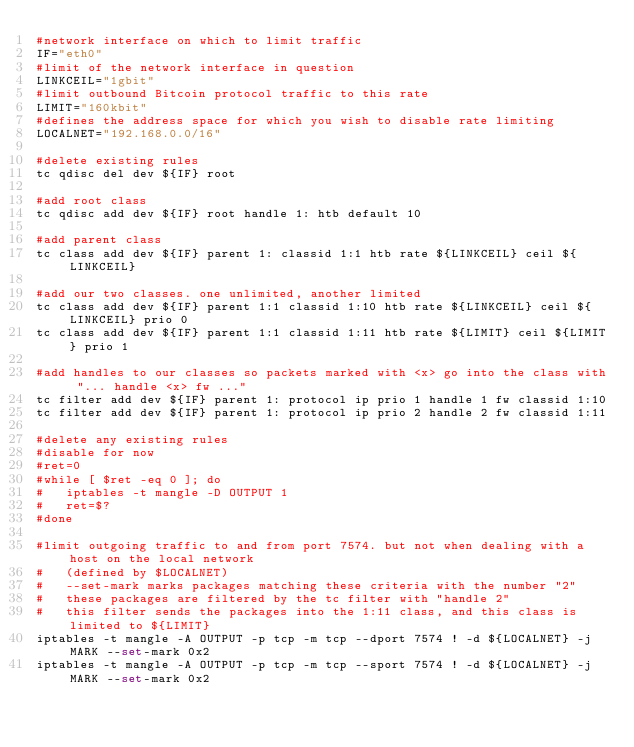<code> <loc_0><loc_0><loc_500><loc_500><_Bash_>#network interface on which to limit traffic
IF="eth0"
#limit of the network interface in question
LINKCEIL="1gbit"
#limit outbound Bitcoin protocol traffic to this rate
LIMIT="160kbit"
#defines the address space for which you wish to disable rate limiting
LOCALNET="192.168.0.0/16"

#delete existing rules
tc qdisc del dev ${IF} root

#add root class
tc qdisc add dev ${IF} root handle 1: htb default 10

#add parent class
tc class add dev ${IF} parent 1: classid 1:1 htb rate ${LINKCEIL} ceil ${LINKCEIL}

#add our two classes. one unlimited, another limited
tc class add dev ${IF} parent 1:1 classid 1:10 htb rate ${LINKCEIL} ceil ${LINKCEIL} prio 0
tc class add dev ${IF} parent 1:1 classid 1:11 htb rate ${LIMIT} ceil ${LIMIT} prio 1

#add handles to our classes so packets marked with <x> go into the class with "... handle <x> fw ..."
tc filter add dev ${IF} parent 1: protocol ip prio 1 handle 1 fw classid 1:10
tc filter add dev ${IF} parent 1: protocol ip prio 2 handle 2 fw classid 1:11

#delete any existing rules
#disable for now
#ret=0
#while [ $ret -eq 0 ]; do
#	iptables -t mangle -D OUTPUT 1
#	ret=$?
#done

#limit outgoing traffic to and from port 7574. but not when dealing with a host on the local network
#	(defined by $LOCALNET)
#	--set-mark marks packages matching these criteria with the number "2"
#	these packages are filtered by the tc filter with "handle 2"
#	this filter sends the packages into the 1:11 class, and this class is limited to ${LIMIT}
iptables -t mangle -A OUTPUT -p tcp -m tcp --dport 7574 ! -d ${LOCALNET} -j MARK --set-mark 0x2
iptables -t mangle -A OUTPUT -p tcp -m tcp --sport 7574 ! -d ${LOCALNET} -j MARK --set-mark 0x2
</code> 